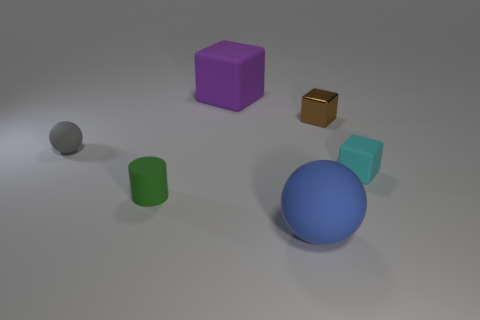What is the color of the rubber cube that is in front of the small brown metal object?
Provide a short and direct response. Cyan. There is a cylinder; is its color the same as the small matte object that is on the right side of the purple rubber block?
Offer a terse response. No. Are there fewer shiny objects than large gray things?
Offer a very short reply. No. Do the matte cube left of the tiny brown metallic thing and the small sphere have the same color?
Keep it short and to the point. No. How many cyan blocks have the same size as the gray thing?
Provide a short and direct response. 1. Are there any other small cylinders of the same color as the tiny matte cylinder?
Provide a succinct answer. No. Are the big purple cube and the tiny gray ball made of the same material?
Keep it short and to the point. Yes. What number of tiny gray things have the same shape as the cyan thing?
Your response must be concise. 0. There is a small gray object that is the same material as the cyan object; what is its shape?
Make the answer very short. Sphere. There is a large object that is behind the block on the right side of the brown thing; what color is it?
Offer a terse response. Purple. 